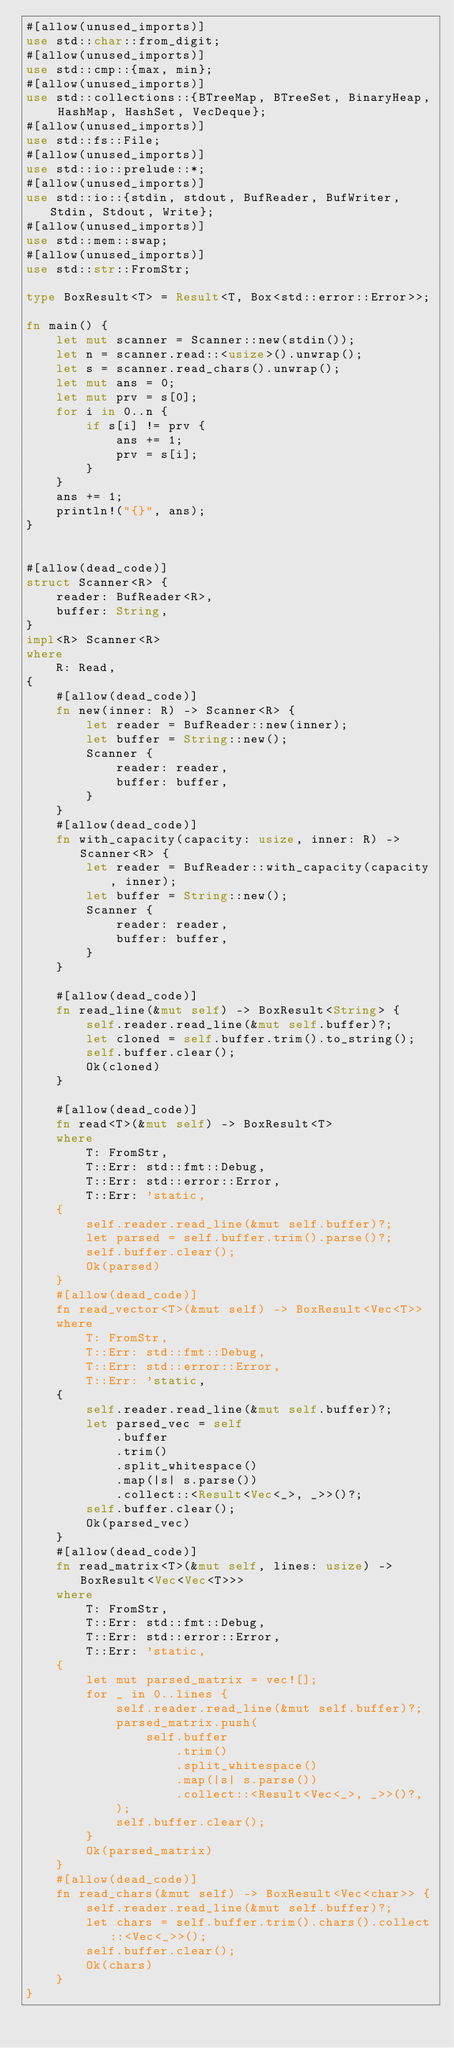<code> <loc_0><loc_0><loc_500><loc_500><_Rust_>#[allow(unused_imports)]
use std::char::from_digit;
#[allow(unused_imports)]
use std::cmp::{max, min};
#[allow(unused_imports)]
use std::collections::{BTreeMap, BTreeSet, BinaryHeap, HashMap, HashSet, VecDeque};
#[allow(unused_imports)]
use std::fs::File;
#[allow(unused_imports)]
use std::io::prelude::*;
#[allow(unused_imports)]
use std::io::{stdin, stdout, BufReader, BufWriter, Stdin, Stdout, Write};
#[allow(unused_imports)]
use std::mem::swap;
#[allow(unused_imports)]
use std::str::FromStr;
 
type BoxResult<T> = Result<T, Box<std::error::Error>>;
 
fn main() {
    let mut scanner = Scanner::new(stdin());
    let n = scanner.read::<usize>().unwrap();
    let s = scanner.read_chars().unwrap();
    let mut ans = 0;
    let mut prv = s[0];
    for i in 0..n {
        if s[i] != prv {
            ans += 1;
            prv = s[i];
        }
    }
    ans += 1;
    println!("{}", ans);
}


#[allow(dead_code)]
struct Scanner<R> {
    reader: BufReader<R>,
    buffer: String,
}
impl<R> Scanner<R>
where
    R: Read,
{
    #[allow(dead_code)]
    fn new(inner: R) -> Scanner<R> {
        let reader = BufReader::new(inner);
        let buffer = String::new();
        Scanner {
            reader: reader,
            buffer: buffer,
        }
    }
    #[allow(dead_code)]
    fn with_capacity(capacity: usize, inner: R) -> Scanner<R> {
        let reader = BufReader::with_capacity(capacity, inner);
        let buffer = String::new();
        Scanner {
            reader: reader,
            buffer: buffer,
        }
    }
 
    #[allow(dead_code)]
    fn read_line(&mut self) -> BoxResult<String> {
        self.reader.read_line(&mut self.buffer)?;
        let cloned = self.buffer.trim().to_string();
        self.buffer.clear();
        Ok(cloned)
    }
 
    #[allow(dead_code)]
    fn read<T>(&mut self) -> BoxResult<T>
    where
        T: FromStr,
        T::Err: std::fmt::Debug,
        T::Err: std::error::Error,
        T::Err: 'static,
    {
        self.reader.read_line(&mut self.buffer)?;
        let parsed = self.buffer.trim().parse()?;
        self.buffer.clear();
        Ok(parsed)
    }
    #[allow(dead_code)]
    fn read_vector<T>(&mut self) -> BoxResult<Vec<T>>
    where
        T: FromStr,
        T::Err: std::fmt::Debug,
        T::Err: std::error::Error,
        T::Err: 'static,
    {
        self.reader.read_line(&mut self.buffer)?;
        let parsed_vec = self
            .buffer
            .trim()
            .split_whitespace()
            .map(|s| s.parse())
            .collect::<Result<Vec<_>, _>>()?;
        self.buffer.clear();
        Ok(parsed_vec)
    }
    #[allow(dead_code)]
    fn read_matrix<T>(&mut self, lines: usize) -> BoxResult<Vec<Vec<T>>>
    where
        T: FromStr,
        T::Err: std::fmt::Debug,
        T::Err: std::error::Error,
        T::Err: 'static,
    {
        let mut parsed_matrix = vec![];
        for _ in 0..lines {
            self.reader.read_line(&mut self.buffer)?;
            parsed_matrix.push(
                self.buffer
                    .trim()
                    .split_whitespace()
                    .map(|s| s.parse())
                    .collect::<Result<Vec<_>, _>>()?,
            );
            self.buffer.clear();
        }
        Ok(parsed_matrix)
    }
    #[allow(dead_code)]
    fn read_chars(&mut self) -> BoxResult<Vec<char>> {
        self.reader.read_line(&mut self.buffer)?;
        let chars = self.buffer.trim().chars().collect::<Vec<_>>();
        self.buffer.clear();
        Ok(chars)
    }
}</code> 